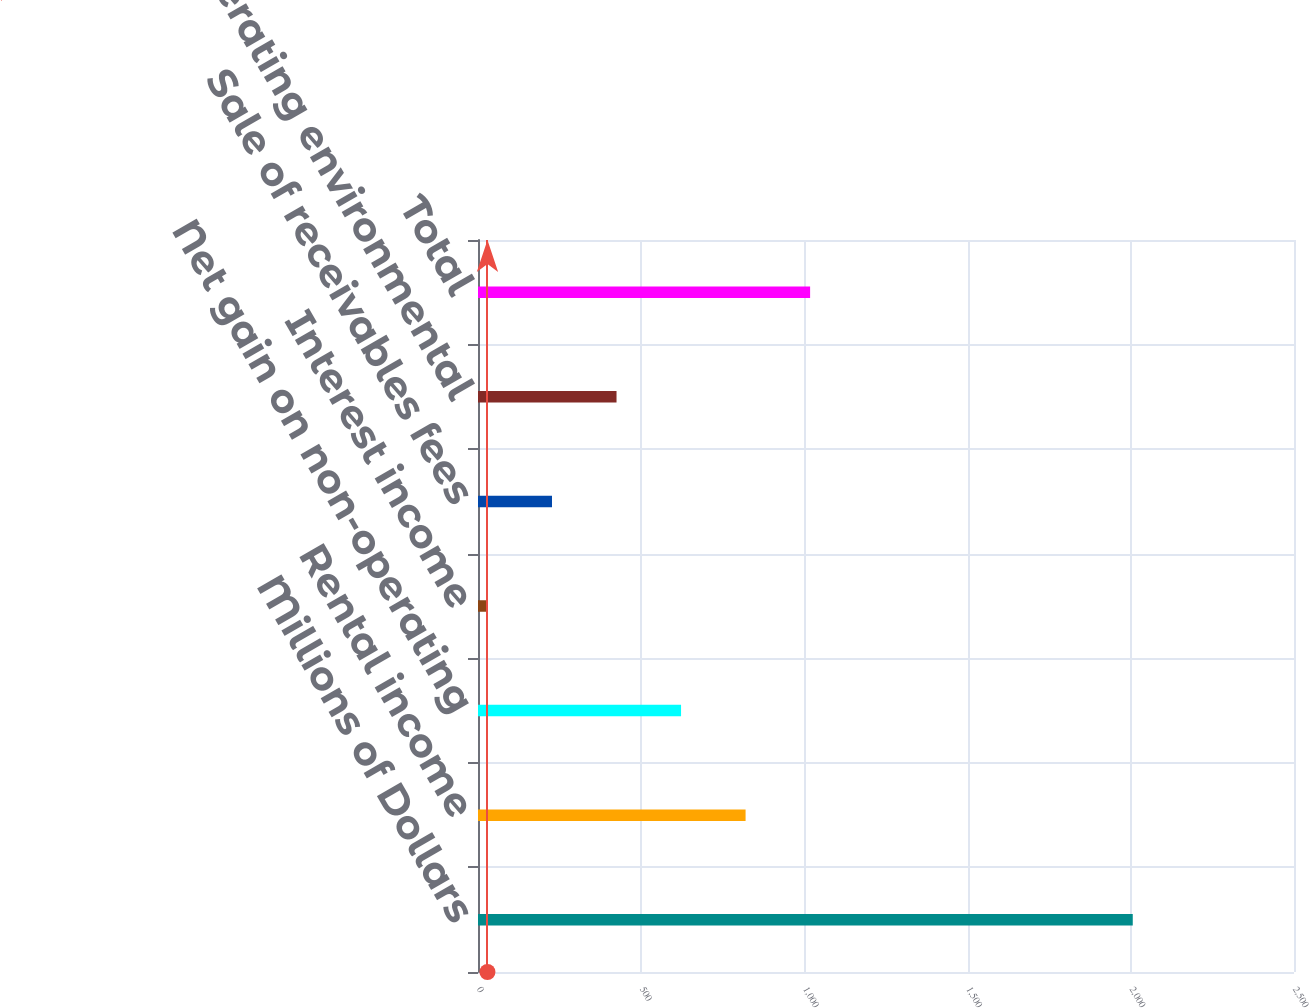Convert chart. <chart><loc_0><loc_0><loc_500><loc_500><bar_chart><fcel>Millions of Dollars<fcel>Rental income<fcel>Net gain on non-operating<fcel>Interest income<fcel>Sale of receivables fees<fcel>Non-operating environmental<fcel>Total<nl><fcel>2006<fcel>819.8<fcel>622.1<fcel>29<fcel>226.7<fcel>424.4<fcel>1017.5<nl></chart> 